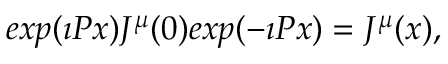Convert formula to latex. <formula><loc_0><loc_0><loc_500><loc_500>e x p ( \imath P x ) J ^ { \mu } ( 0 ) e x p ( - \imath P x ) = J ^ { \mu } ( x ) ,</formula> 